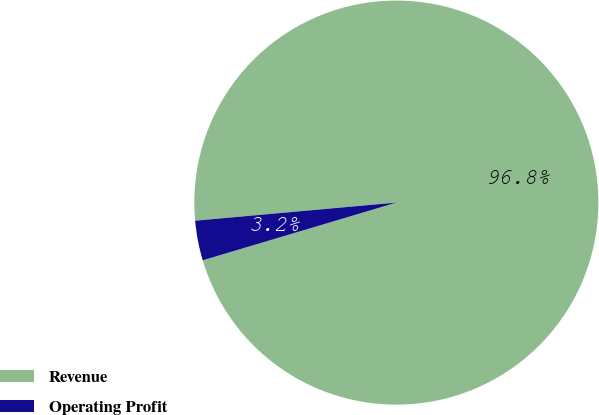<chart> <loc_0><loc_0><loc_500><loc_500><pie_chart><fcel>Revenue<fcel>Operating Profit<nl><fcel>96.82%<fcel>3.18%<nl></chart> 